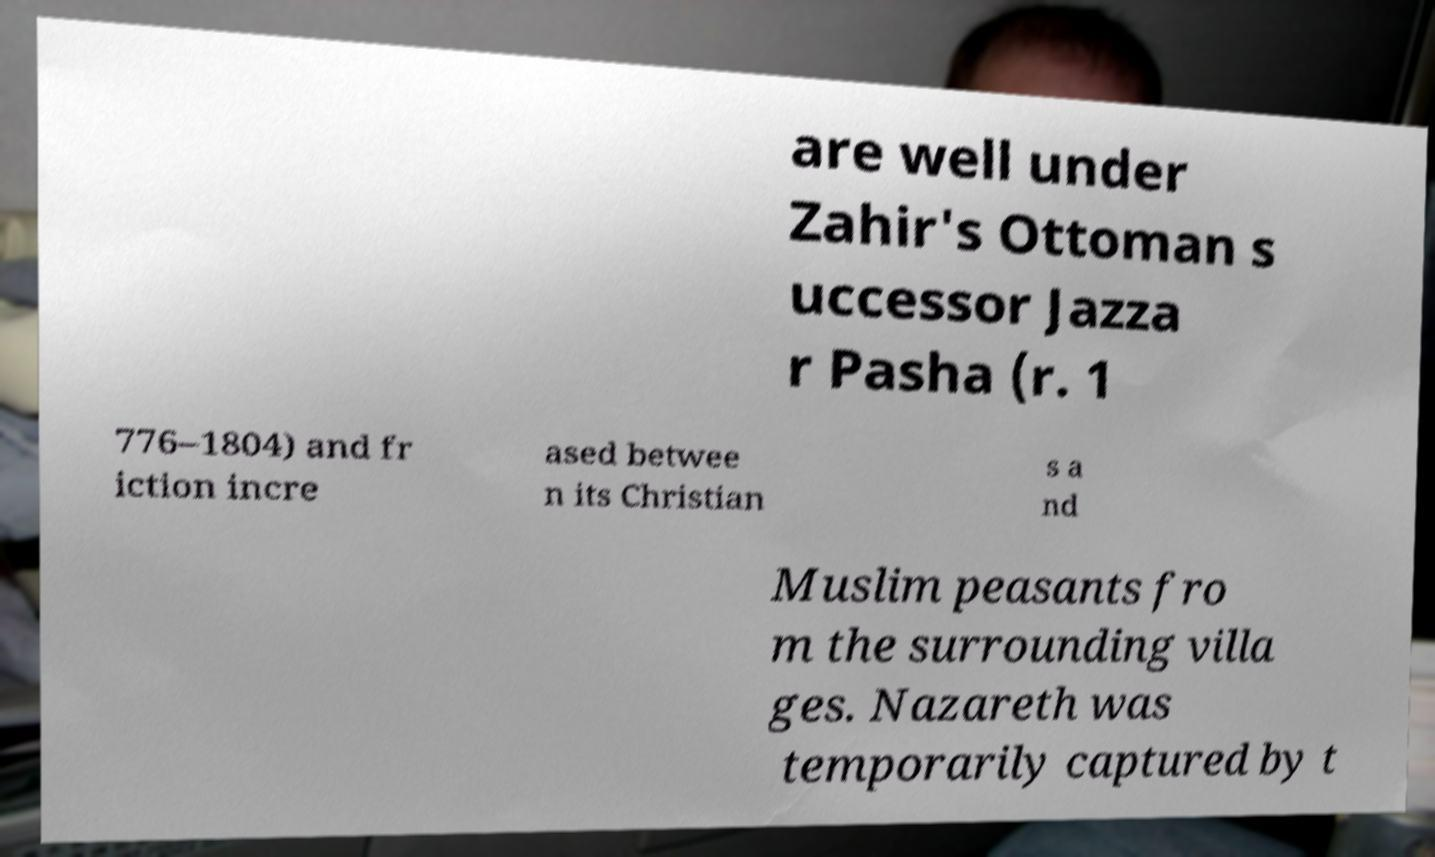Could you assist in decoding the text presented in this image and type it out clearly? are well under Zahir's Ottoman s uccessor Jazza r Pasha (r. 1 776–1804) and fr iction incre ased betwee n its Christian s a nd Muslim peasants fro m the surrounding villa ges. Nazareth was temporarily captured by t 